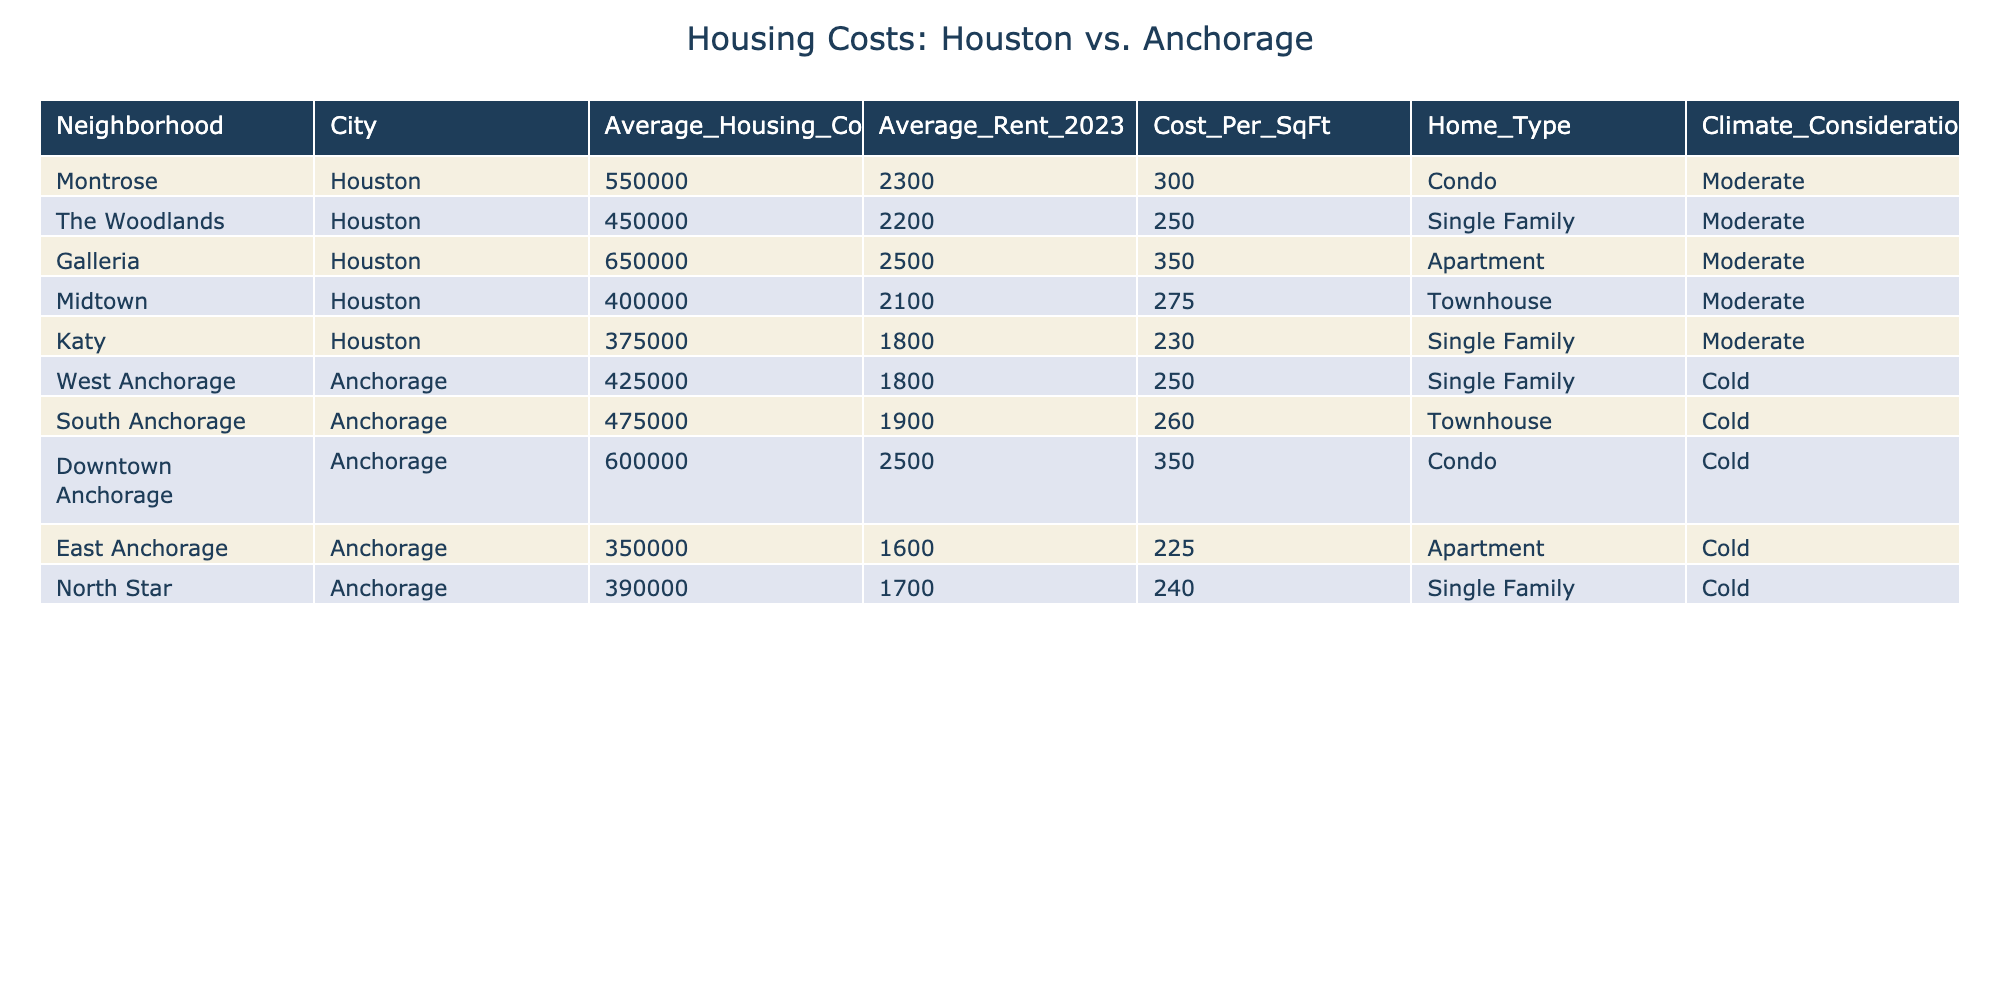What is the average housing cost in Houston? To find the average housing cost in Houston, we sum the average housing costs of the Houston neighborhoods: 550,000 + 450,000 + 650,000 + 400,000 + 375,000 = 2,425,000. There are 5 neighborhoods, so we divide by 5: 2,425,000 / 5 = 485,000.
Answer: 485,000 Which neighborhood in Anchorage has the highest average rent? In the table, we can see that Downtown Anchorage has the highest average rent at 2,500.
Answer: 2,500 What is the cost per square foot for The Woodlands neighborhood? The cost per square foot for The Woodlands neighborhood is listed as 250 in the table.
Answer: 250 Is the average rent higher in Houston or Anchorage? To determine this, we compare the average rents of all neighborhoods in each city. The average rent in Houston is (2,300 + 2,200 + 2,500 + 2,100 + 1,800) / 5 = 2,180. The average rent in Anchorage is (1,800 + 1,900 + 2,500 + 1,600 + 1,700) / 5 = 1,900. Since 2,180 is greater than 1,900, the average rent is higher in Houston.
Answer: Higher in Houston What is the difference in average housing costs between the most expensive neighborhood in Houston and the most expensive in Anchorage? The most expensive neighborhood in Houston is the Galleria at 650,000, and in Anchorage, it is Downtown Anchorage at 600,000. The difference in their costs is 650,000 - 600,000 = 50,000.
Answer: 50,000 Which type of home has the lowest average housing cost in Anchorage? The lowest average housing cost in Anchorage is found in East Anchorage, which has an average housing cost of 350,000.
Answer: Apartment How many Houston neighborhoods have a higher average housing cost than the most expensive neighborhood in Anchorage? The most expensive neighborhood in Anchorage is Downtown Anchorage at 600,000. In Houston, the Galleria (650,000) is the only neighborhood that exceeds this cost. Therefore, there is one neighborhood in Houston that is more expensive than Anchorage's most expensive.
Answer: 1 What is the average cost per square foot across all neighborhoods in both cities? For Houston, the average cost per square foot is (300 + 250 + 350 + 275 + 230) / 5 = 281. For Anchorage, it is (250 + 260 + 350 + 225 + 240) / 5 = 265. The overall average is (281 + 265) / 2 = 273.
Answer: 273 Are there any single-family homes in Anchorage that are cheaper than the cheapest single-family home in Houston? The cheapest single-family home in Houston is in Katy at 375,000. In Anchorage, the North Star is listed at 390,000, which is more expensive. Therefore, there are no single-family homes in Anchorage that are cheaper than those in Katy.
Answer: No What is the average rent for townhouses in both cities? In Houston, the average rent for townhouses is 2,100 (Midtown), and in Anchorage, it is 1,900 (South Anchorage). The combined average is (2,100 + 1,900) / 2 = 2,000.
Answer: 2,000 Which neighborhood has the lowest average rent in Houston? The table shows that Katy has the lowest average rent at 1,800.
Answer: Katy 